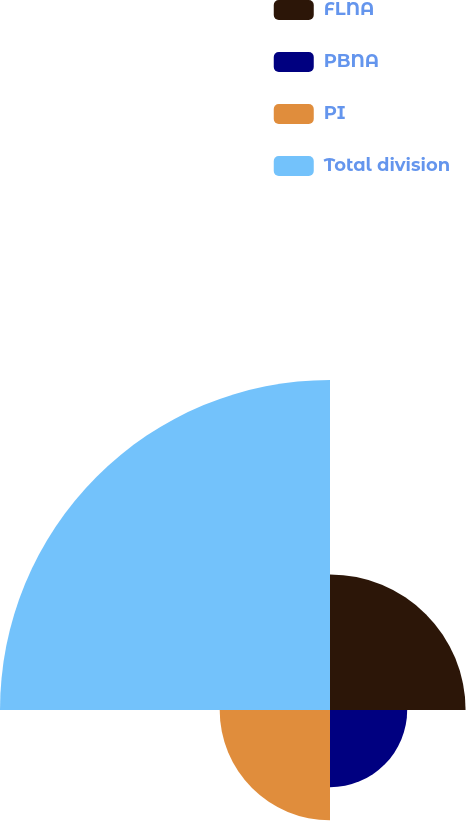Convert chart. <chart><loc_0><loc_0><loc_500><loc_500><pie_chart><fcel>FLNA<fcel>PBNA<fcel>PI<fcel>Total division<nl><fcel>20.76%<fcel>11.82%<fcel>16.89%<fcel>50.53%<nl></chart> 